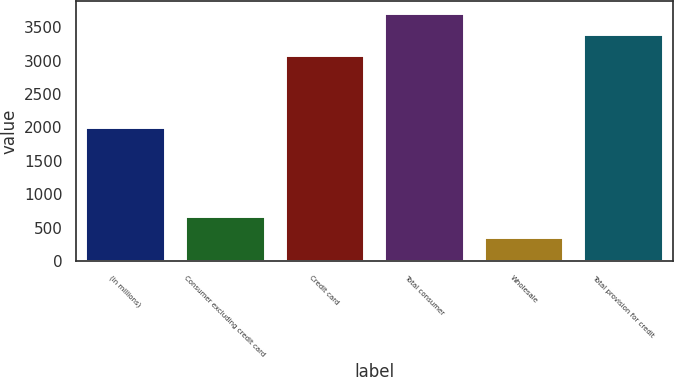Convert chart. <chart><loc_0><loc_0><loc_500><loc_500><bar_chart><fcel>(in millions)<fcel>Consumer excluding credit card<fcel>Credit card<fcel>Total consumer<fcel>Wholesale<fcel>Total provision for credit<nl><fcel>2014<fcel>672.9<fcel>3079<fcel>3706.8<fcel>359<fcel>3392.9<nl></chart> 